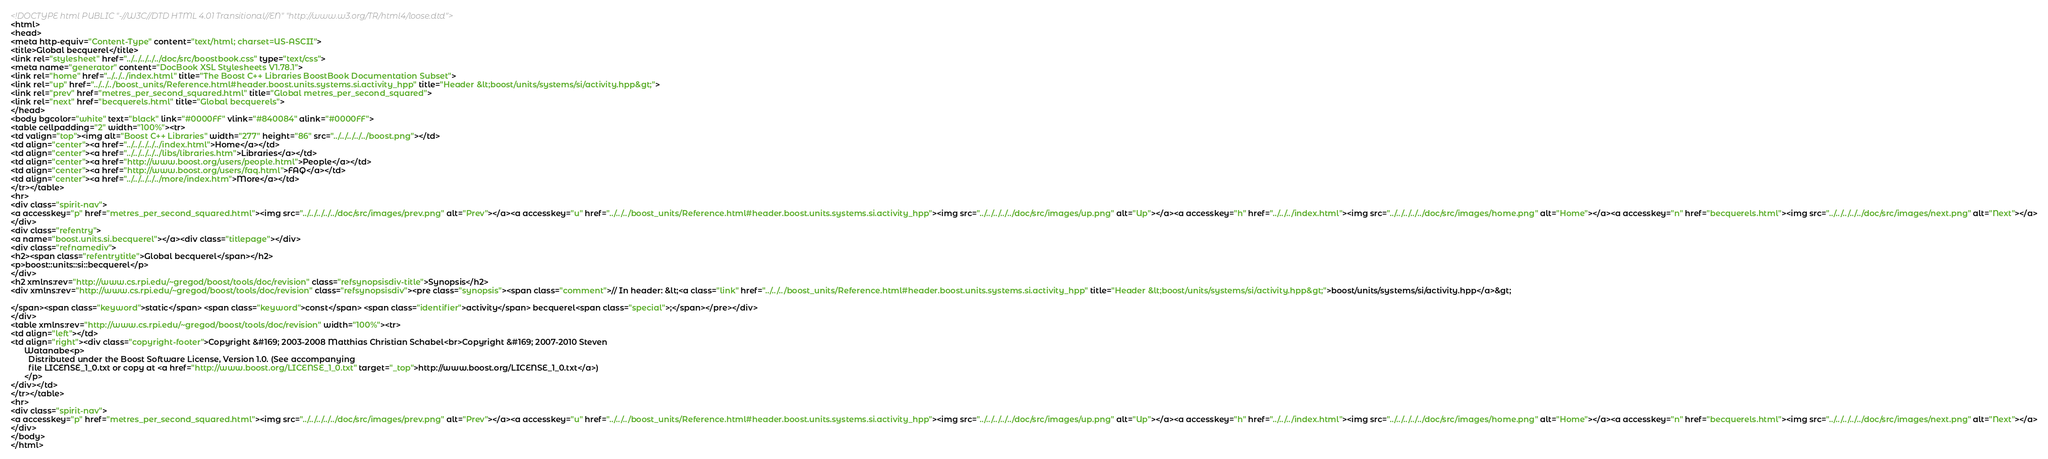Convert code to text. <code><loc_0><loc_0><loc_500><loc_500><_HTML_><!DOCTYPE html PUBLIC "-//W3C//DTD HTML 4.01 Transitional//EN" "http://www.w3.org/TR/html4/loose.dtd">
<html>
<head>
<meta http-equiv="Content-Type" content="text/html; charset=US-ASCII">
<title>Global becquerel</title>
<link rel="stylesheet" href="../../../../../doc/src/boostbook.css" type="text/css">
<meta name="generator" content="DocBook XSL Stylesheets V1.78.1">
<link rel="home" href="../../../index.html" title="The Boost C++ Libraries BoostBook Documentation Subset">
<link rel="up" href="../../../boost_units/Reference.html#header.boost.units.systems.si.activity_hpp" title="Header &lt;boost/units/systems/si/activity.hpp&gt;">
<link rel="prev" href="metres_per_second_squared.html" title="Global metres_per_second_squared">
<link rel="next" href="becquerels.html" title="Global becquerels">
</head>
<body bgcolor="white" text="black" link="#0000FF" vlink="#840084" alink="#0000FF">
<table cellpadding="2" width="100%"><tr>
<td valign="top"><img alt="Boost C++ Libraries" width="277" height="86" src="../../../../../boost.png"></td>
<td align="center"><a href="../../../../../index.html">Home</a></td>
<td align="center"><a href="../../../../../libs/libraries.htm">Libraries</a></td>
<td align="center"><a href="http://www.boost.org/users/people.html">People</a></td>
<td align="center"><a href="http://www.boost.org/users/faq.html">FAQ</a></td>
<td align="center"><a href="../../../../../more/index.htm">More</a></td>
</tr></table>
<hr>
<div class="spirit-nav">
<a accesskey="p" href="metres_per_second_squared.html"><img src="../../../../../doc/src/images/prev.png" alt="Prev"></a><a accesskey="u" href="../../../boost_units/Reference.html#header.boost.units.systems.si.activity_hpp"><img src="../../../../../doc/src/images/up.png" alt="Up"></a><a accesskey="h" href="../../../index.html"><img src="../../../../../doc/src/images/home.png" alt="Home"></a><a accesskey="n" href="becquerels.html"><img src="../../../../../doc/src/images/next.png" alt="Next"></a>
</div>
<div class="refentry">
<a name="boost.units.si.becquerel"></a><div class="titlepage"></div>
<div class="refnamediv">
<h2><span class="refentrytitle">Global becquerel</span></h2>
<p>boost::units::si::becquerel</p>
</div>
<h2 xmlns:rev="http://www.cs.rpi.edu/~gregod/boost/tools/doc/revision" class="refsynopsisdiv-title">Synopsis</h2>
<div xmlns:rev="http://www.cs.rpi.edu/~gregod/boost/tools/doc/revision" class="refsynopsisdiv"><pre class="synopsis"><span class="comment">// In header: &lt;<a class="link" href="../../../boost_units/Reference.html#header.boost.units.systems.si.activity_hpp" title="Header &lt;boost/units/systems/si/activity.hpp&gt;">boost/units/systems/si/activity.hpp</a>&gt;

</span><span class="keyword">static</span> <span class="keyword">const</span> <span class="identifier">activity</span> becquerel<span class="special">;</span></pre></div>
</div>
<table xmlns:rev="http://www.cs.rpi.edu/~gregod/boost/tools/doc/revision" width="100%"><tr>
<td align="left"></td>
<td align="right"><div class="copyright-footer">Copyright &#169; 2003-2008 Matthias Christian Schabel<br>Copyright &#169; 2007-2010 Steven
      Watanabe<p>
        Distributed under the Boost Software License, Version 1.0. (See accompanying
        file LICENSE_1_0.txt or copy at <a href="http://www.boost.org/LICENSE_1_0.txt" target="_top">http://www.boost.org/LICENSE_1_0.txt</a>)
      </p>
</div></td>
</tr></table>
<hr>
<div class="spirit-nav">
<a accesskey="p" href="metres_per_second_squared.html"><img src="../../../../../doc/src/images/prev.png" alt="Prev"></a><a accesskey="u" href="../../../boost_units/Reference.html#header.boost.units.systems.si.activity_hpp"><img src="../../../../../doc/src/images/up.png" alt="Up"></a><a accesskey="h" href="../../../index.html"><img src="../../../../../doc/src/images/home.png" alt="Home"></a><a accesskey="n" href="becquerels.html"><img src="../../../../../doc/src/images/next.png" alt="Next"></a>
</div>
</body>
</html>
</code> 